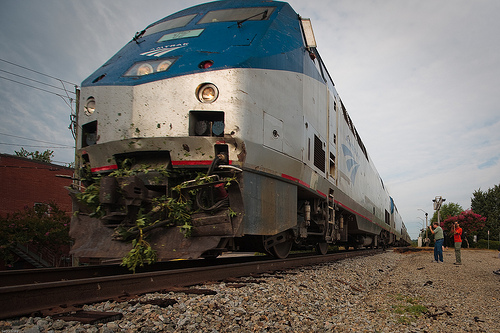<image>
Can you confirm if the train is in front of the man? No. The train is not in front of the man. The spatial positioning shows a different relationship between these objects. 